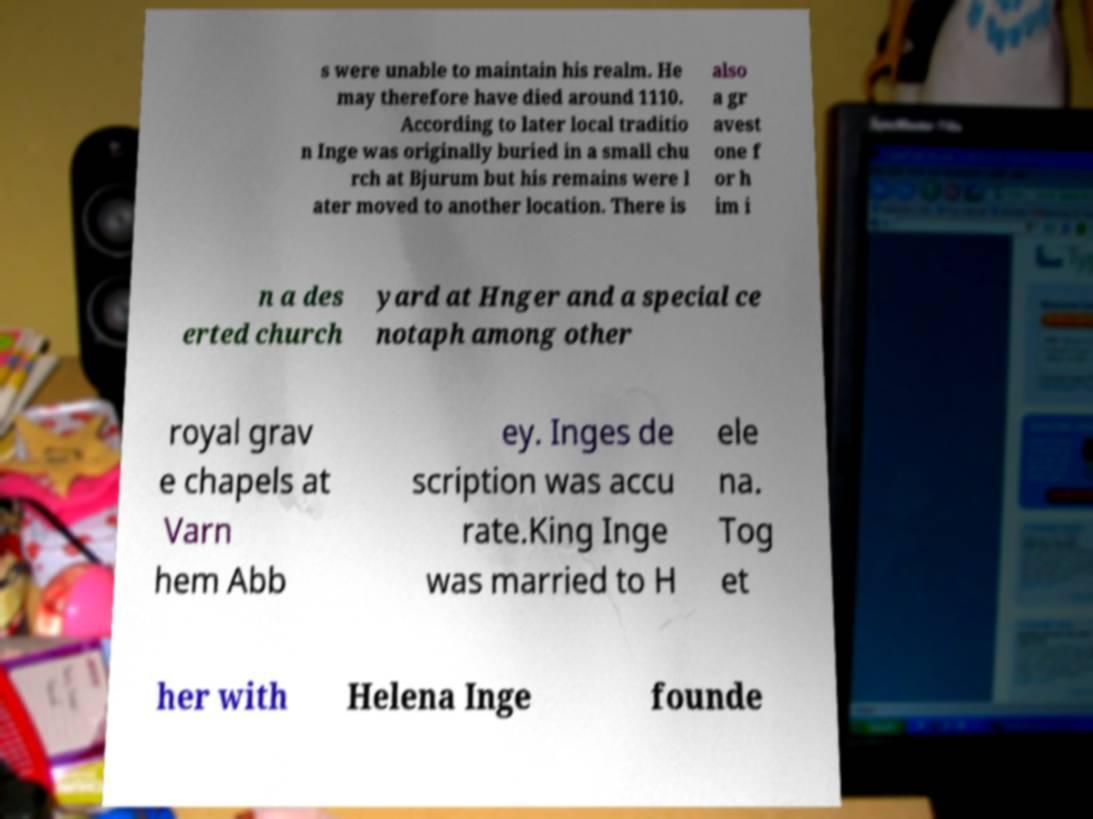Could you extract and type out the text from this image? s were unable to maintain his realm. He may therefore have died around 1110. According to later local traditio n Inge was originally buried in a small chu rch at Bjurum but his remains were l ater moved to another location. There is also a gr avest one f or h im i n a des erted church yard at Hnger and a special ce notaph among other royal grav e chapels at Varn hem Abb ey. Inges de scription was accu rate.King Inge was married to H ele na. Tog et her with Helena Inge founde 